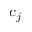<formula> <loc_0><loc_0><loc_500><loc_500>c _ { j }</formula> 